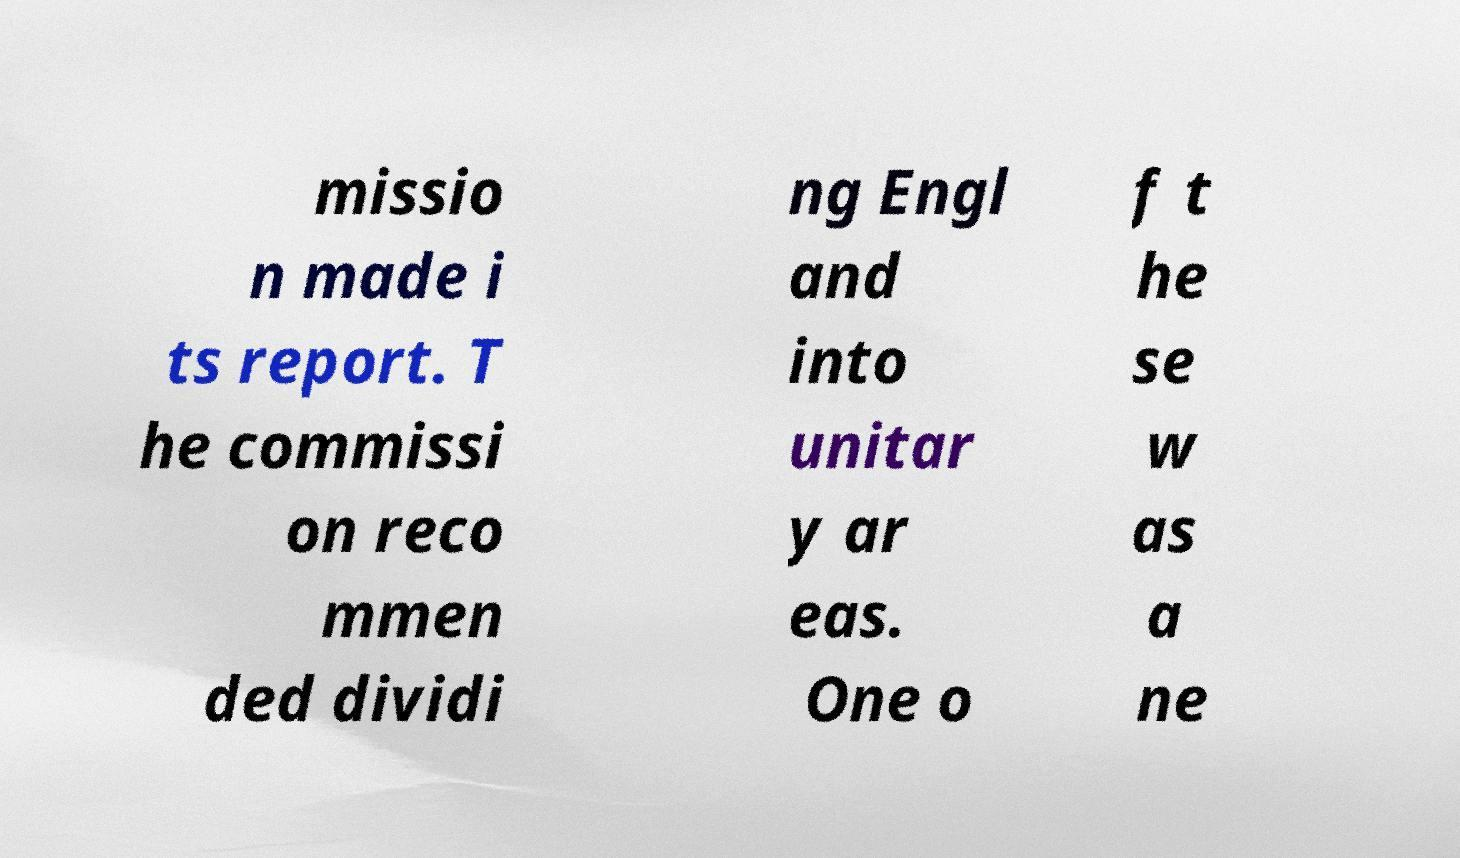There's text embedded in this image that I need extracted. Can you transcribe it verbatim? missio n made i ts report. T he commissi on reco mmen ded dividi ng Engl and into unitar y ar eas. One o f t he se w as a ne 